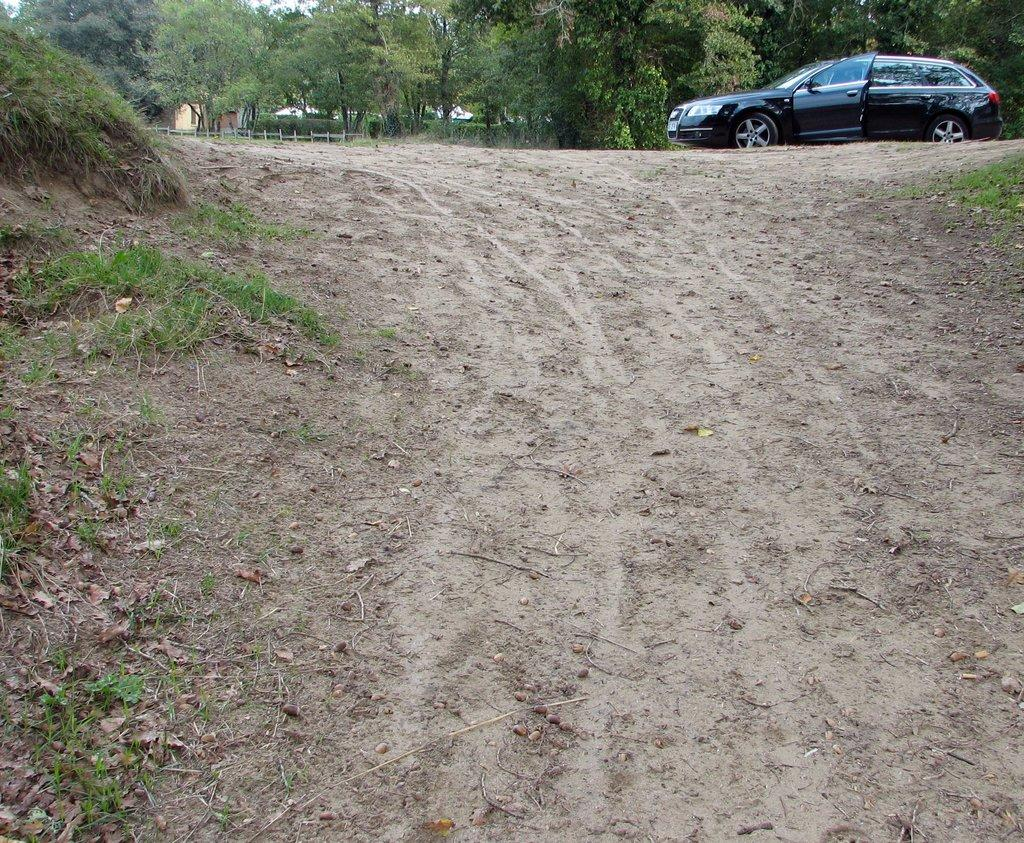What type of surface is visible in the image? There is soil in the image. What type of vegetation is on the left side of the image? There is grass on the left side of the image. What type of vehicle is parked in the image? There is a car parked in the image. What can be seen in the background of the image? There are trees and a building in the background of the image. What type of eggnog is being served at the family gathering in the image? There is no family gathering or eggnog present in the image. What is the condition of the roof in the image? There is no roof present in the image. 